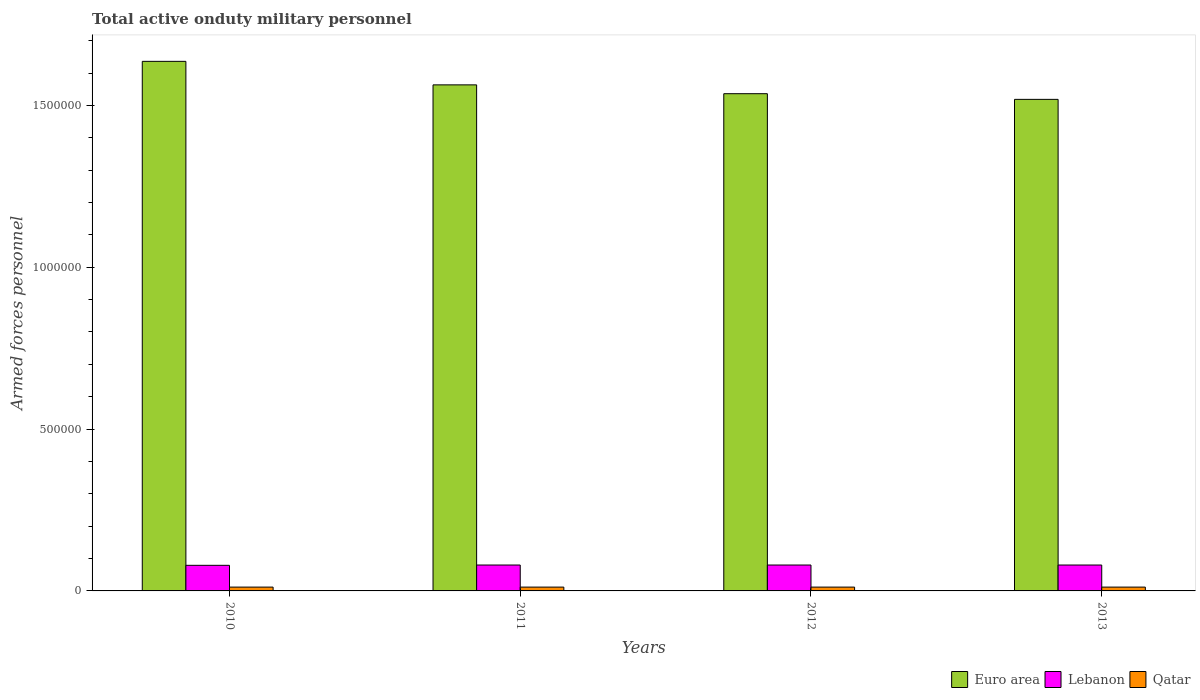Are the number of bars per tick equal to the number of legend labels?
Provide a short and direct response. Yes. How many bars are there on the 3rd tick from the left?
Keep it short and to the point. 3. What is the label of the 1st group of bars from the left?
Provide a succinct answer. 2010. What is the number of armed forces personnel in Lebanon in 2012?
Make the answer very short. 8.00e+04. Across all years, what is the maximum number of armed forces personnel in Lebanon?
Provide a short and direct response. 8.00e+04. Across all years, what is the minimum number of armed forces personnel in Lebanon?
Your response must be concise. 7.91e+04. What is the total number of armed forces personnel in Qatar in the graph?
Keep it short and to the point. 4.72e+04. What is the difference between the number of armed forces personnel in Lebanon in 2010 and that in 2011?
Give a very brief answer. -900. What is the difference between the number of armed forces personnel in Lebanon in 2012 and the number of armed forces personnel in Qatar in 2013?
Your response must be concise. 6.82e+04. What is the average number of armed forces personnel in Qatar per year?
Offer a terse response. 1.18e+04. In the year 2011, what is the difference between the number of armed forces personnel in Qatar and number of armed forces personnel in Lebanon?
Offer a terse response. -6.82e+04. In how many years, is the number of armed forces personnel in Qatar greater than 600000?
Keep it short and to the point. 0. Is the number of armed forces personnel in Euro area in 2012 less than that in 2013?
Offer a terse response. No. What is the difference between the highest and the lowest number of armed forces personnel in Lebanon?
Keep it short and to the point. 900. In how many years, is the number of armed forces personnel in Qatar greater than the average number of armed forces personnel in Qatar taken over all years?
Offer a very short reply. 0. Is the sum of the number of armed forces personnel in Qatar in 2010 and 2013 greater than the maximum number of armed forces personnel in Euro area across all years?
Your answer should be very brief. No. What does the 2nd bar from the right in 2010 represents?
Your response must be concise. Lebanon. Is it the case that in every year, the sum of the number of armed forces personnel in Euro area and number of armed forces personnel in Lebanon is greater than the number of armed forces personnel in Qatar?
Keep it short and to the point. Yes. How many bars are there?
Your answer should be very brief. 12. Are all the bars in the graph horizontal?
Make the answer very short. No. What is the difference between two consecutive major ticks on the Y-axis?
Provide a succinct answer. 5.00e+05. Are the values on the major ticks of Y-axis written in scientific E-notation?
Keep it short and to the point. No. Does the graph contain any zero values?
Ensure brevity in your answer.  No. Does the graph contain grids?
Provide a succinct answer. No. Where does the legend appear in the graph?
Keep it short and to the point. Bottom right. What is the title of the graph?
Offer a terse response. Total active onduty military personnel. What is the label or title of the X-axis?
Your answer should be very brief. Years. What is the label or title of the Y-axis?
Your answer should be very brief. Armed forces personnel. What is the Armed forces personnel of Euro area in 2010?
Make the answer very short. 1.64e+06. What is the Armed forces personnel of Lebanon in 2010?
Your response must be concise. 7.91e+04. What is the Armed forces personnel of Qatar in 2010?
Your response must be concise. 1.18e+04. What is the Armed forces personnel in Euro area in 2011?
Give a very brief answer. 1.56e+06. What is the Armed forces personnel in Qatar in 2011?
Keep it short and to the point. 1.18e+04. What is the Armed forces personnel of Euro area in 2012?
Make the answer very short. 1.54e+06. What is the Armed forces personnel in Lebanon in 2012?
Offer a terse response. 8.00e+04. What is the Armed forces personnel of Qatar in 2012?
Provide a short and direct response. 1.18e+04. What is the Armed forces personnel of Euro area in 2013?
Keep it short and to the point. 1.52e+06. What is the Armed forces personnel of Qatar in 2013?
Make the answer very short. 1.18e+04. Across all years, what is the maximum Armed forces personnel of Euro area?
Ensure brevity in your answer.  1.64e+06. Across all years, what is the maximum Armed forces personnel in Lebanon?
Make the answer very short. 8.00e+04. Across all years, what is the maximum Armed forces personnel of Qatar?
Keep it short and to the point. 1.18e+04. Across all years, what is the minimum Armed forces personnel of Euro area?
Keep it short and to the point. 1.52e+06. Across all years, what is the minimum Armed forces personnel in Lebanon?
Ensure brevity in your answer.  7.91e+04. Across all years, what is the minimum Armed forces personnel in Qatar?
Provide a succinct answer. 1.18e+04. What is the total Armed forces personnel of Euro area in the graph?
Keep it short and to the point. 6.25e+06. What is the total Armed forces personnel in Lebanon in the graph?
Offer a very short reply. 3.19e+05. What is the total Armed forces personnel in Qatar in the graph?
Keep it short and to the point. 4.72e+04. What is the difference between the Armed forces personnel of Euro area in 2010 and that in 2011?
Your response must be concise. 7.27e+04. What is the difference between the Armed forces personnel in Lebanon in 2010 and that in 2011?
Keep it short and to the point. -900. What is the difference between the Armed forces personnel in Qatar in 2010 and that in 2011?
Offer a terse response. 0. What is the difference between the Armed forces personnel of Euro area in 2010 and that in 2012?
Provide a short and direct response. 9.99e+04. What is the difference between the Armed forces personnel of Lebanon in 2010 and that in 2012?
Provide a succinct answer. -900. What is the difference between the Armed forces personnel of Qatar in 2010 and that in 2012?
Provide a succinct answer. 0. What is the difference between the Armed forces personnel of Euro area in 2010 and that in 2013?
Ensure brevity in your answer.  1.17e+05. What is the difference between the Armed forces personnel of Lebanon in 2010 and that in 2013?
Your answer should be very brief. -900. What is the difference between the Armed forces personnel of Qatar in 2010 and that in 2013?
Your answer should be compact. 0. What is the difference between the Armed forces personnel of Euro area in 2011 and that in 2012?
Provide a short and direct response. 2.73e+04. What is the difference between the Armed forces personnel in Lebanon in 2011 and that in 2012?
Provide a succinct answer. 0. What is the difference between the Armed forces personnel of Qatar in 2011 and that in 2012?
Offer a very short reply. 0. What is the difference between the Armed forces personnel in Euro area in 2011 and that in 2013?
Your answer should be compact. 4.48e+04. What is the difference between the Armed forces personnel of Qatar in 2011 and that in 2013?
Offer a terse response. 0. What is the difference between the Armed forces personnel of Euro area in 2012 and that in 2013?
Your answer should be very brief. 1.75e+04. What is the difference between the Armed forces personnel in Euro area in 2010 and the Armed forces personnel in Lebanon in 2011?
Provide a succinct answer. 1.56e+06. What is the difference between the Armed forces personnel in Euro area in 2010 and the Armed forces personnel in Qatar in 2011?
Your answer should be compact. 1.62e+06. What is the difference between the Armed forces personnel in Lebanon in 2010 and the Armed forces personnel in Qatar in 2011?
Provide a succinct answer. 6.73e+04. What is the difference between the Armed forces personnel of Euro area in 2010 and the Armed forces personnel of Lebanon in 2012?
Provide a short and direct response. 1.56e+06. What is the difference between the Armed forces personnel in Euro area in 2010 and the Armed forces personnel in Qatar in 2012?
Your response must be concise. 1.62e+06. What is the difference between the Armed forces personnel of Lebanon in 2010 and the Armed forces personnel of Qatar in 2012?
Keep it short and to the point. 6.73e+04. What is the difference between the Armed forces personnel in Euro area in 2010 and the Armed forces personnel in Lebanon in 2013?
Keep it short and to the point. 1.56e+06. What is the difference between the Armed forces personnel in Euro area in 2010 and the Armed forces personnel in Qatar in 2013?
Your answer should be compact. 1.62e+06. What is the difference between the Armed forces personnel in Lebanon in 2010 and the Armed forces personnel in Qatar in 2013?
Give a very brief answer. 6.73e+04. What is the difference between the Armed forces personnel in Euro area in 2011 and the Armed forces personnel in Lebanon in 2012?
Your response must be concise. 1.48e+06. What is the difference between the Armed forces personnel of Euro area in 2011 and the Armed forces personnel of Qatar in 2012?
Your response must be concise. 1.55e+06. What is the difference between the Armed forces personnel in Lebanon in 2011 and the Armed forces personnel in Qatar in 2012?
Your response must be concise. 6.82e+04. What is the difference between the Armed forces personnel of Euro area in 2011 and the Armed forces personnel of Lebanon in 2013?
Your answer should be very brief. 1.48e+06. What is the difference between the Armed forces personnel of Euro area in 2011 and the Armed forces personnel of Qatar in 2013?
Offer a very short reply. 1.55e+06. What is the difference between the Armed forces personnel in Lebanon in 2011 and the Armed forces personnel in Qatar in 2013?
Provide a succinct answer. 6.82e+04. What is the difference between the Armed forces personnel of Euro area in 2012 and the Armed forces personnel of Lebanon in 2013?
Provide a succinct answer. 1.46e+06. What is the difference between the Armed forces personnel in Euro area in 2012 and the Armed forces personnel in Qatar in 2013?
Your response must be concise. 1.52e+06. What is the difference between the Armed forces personnel in Lebanon in 2012 and the Armed forces personnel in Qatar in 2013?
Offer a terse response. 6.82e+04. What is the average Armed forces personnel of Euro area per year?
Provide a short and direct response. 1.56e+06. What is the average Armed forces personnel in Lebanon per year?
Ensure brevity in your answer.  7.98e+04. What is the average Armed forces personnel in Qatar per year?
Offer a terse response. 1.18e+04. In the year 2010, what is the difference between the Armed forces personnel in Euro area and Armed forces personnel in Lebanon?
Provide a succinct answer. 1.56e+06. In the year 2010, what is the difference between the Armed forces personnel of Euro area and Armed forces personnel of Qatar?
Offer a very short reply. 1.62e+06. In the year 2010, what is the difference between the Armed forces personnel of Lebanon and Armed forces personnel of Qatar?
Give a very brief answer. 6.73e+04. In the year 2011, what is the difference between the Armed forces personnel of Euro area and Armed forces personnel of Lebanon?
Make the answer very short. 1.48e+06. In the year 2011, what is the difference between the Armed forces personnel of Euro area and Armed forces personnel of Qatar?
Your answer should be very brief. 1.55e+06. In the year 2011, what is the difference between the Armed forces personnel in Lebanon and Armed forces personnel in Qatar?
Your answer should be compact. 6.82e+04. In the year 2012, what is the difference between the Armed forces personnel in Euro area and Armed forces personnel in Lebanon?
Provide a succinct answer. 1.46e+06. In the year 2012, what is the difference between the Armed forces personnel of Euro area and Armed forces personnel of Qatar?
Provide a short and direct response. 1.52e+06. In the year 2012, what is the difference between the Armed forces personnel of Lebanon and Armed forces personnel of Qatar?
Your answer should be very brief. 6.82e+04. In the year 2013, what is the difference between the Armed forces personnel of Euro area and Armed forces personnel of Lebanon?
Provide a succinct answer. 1.44e+06. In the year 2013, what is the difference between the Armed forces personnel in Euro area and Armed forces personnel in Qatar?
Provide a short and direct response. 1.51e+06. In the year 2013, what is the difference between the Armed forces personnel in Lebanon and Armed forces personnel in Qatar?
Provide a short and direct response. 6.82e+04. What is the ratio of the Armed forces personnel in Euro area in 2010 to that in 2011?
Keep it short and to the point. 1.05. What is the ratio of the Armed forces personnel of Euro area in 2010 to that in 2012?
Your answer should be compact. 1.07. What is the ratio of the Armed forces personnel of Qatar in 2010 to that in 2012?
Make the answer very short. 1. What is the ratio of the Armed forces personnel in Euro area in 2010 to that in 2013?
Offer a terse response. 1.08. What is the ratio of the Armed forces personnel in Euro area in 2011 to that in 2012?
Make the answer very short. 1.02. What is the ratio of the Armed forces personnel in Lebanon in 2011 to that in 2012?
Provide a short and direct response. 1. What is the ratio of the Armed forces personnel of Qatar in 2011 to that in 2012?
Your response must be concise. 1. What is the ratio of the Armed forces personnel in Euro area in 2011 to that in 2013?
Your answer should be compact. 1.03. What is the ratio of the Armed forces personnel in Euro area in 2012 to that in 2013?
Offer a terse response. 1.01. What is the difference between the highest and the second highest Armed forces personnel in Euro area?
Offer a very short reply. 7.27e+04. What is the difference between the highest and the second highest Armed forces personnel of Lebanon?
Your answer should be very brief. 0. What is the difference between the highest and the lowest Armed forces personnel in Euro area?
Offer a very short reply. 1.17e+05. What is the difference between the highest and the lowest Armed forces personnel of Lebanon?
Ensure brevity in your answer.  900. What is the difference between the highest and the lowest Armed forces personnel of Qatar?
Provide a succinct answer. 0. 